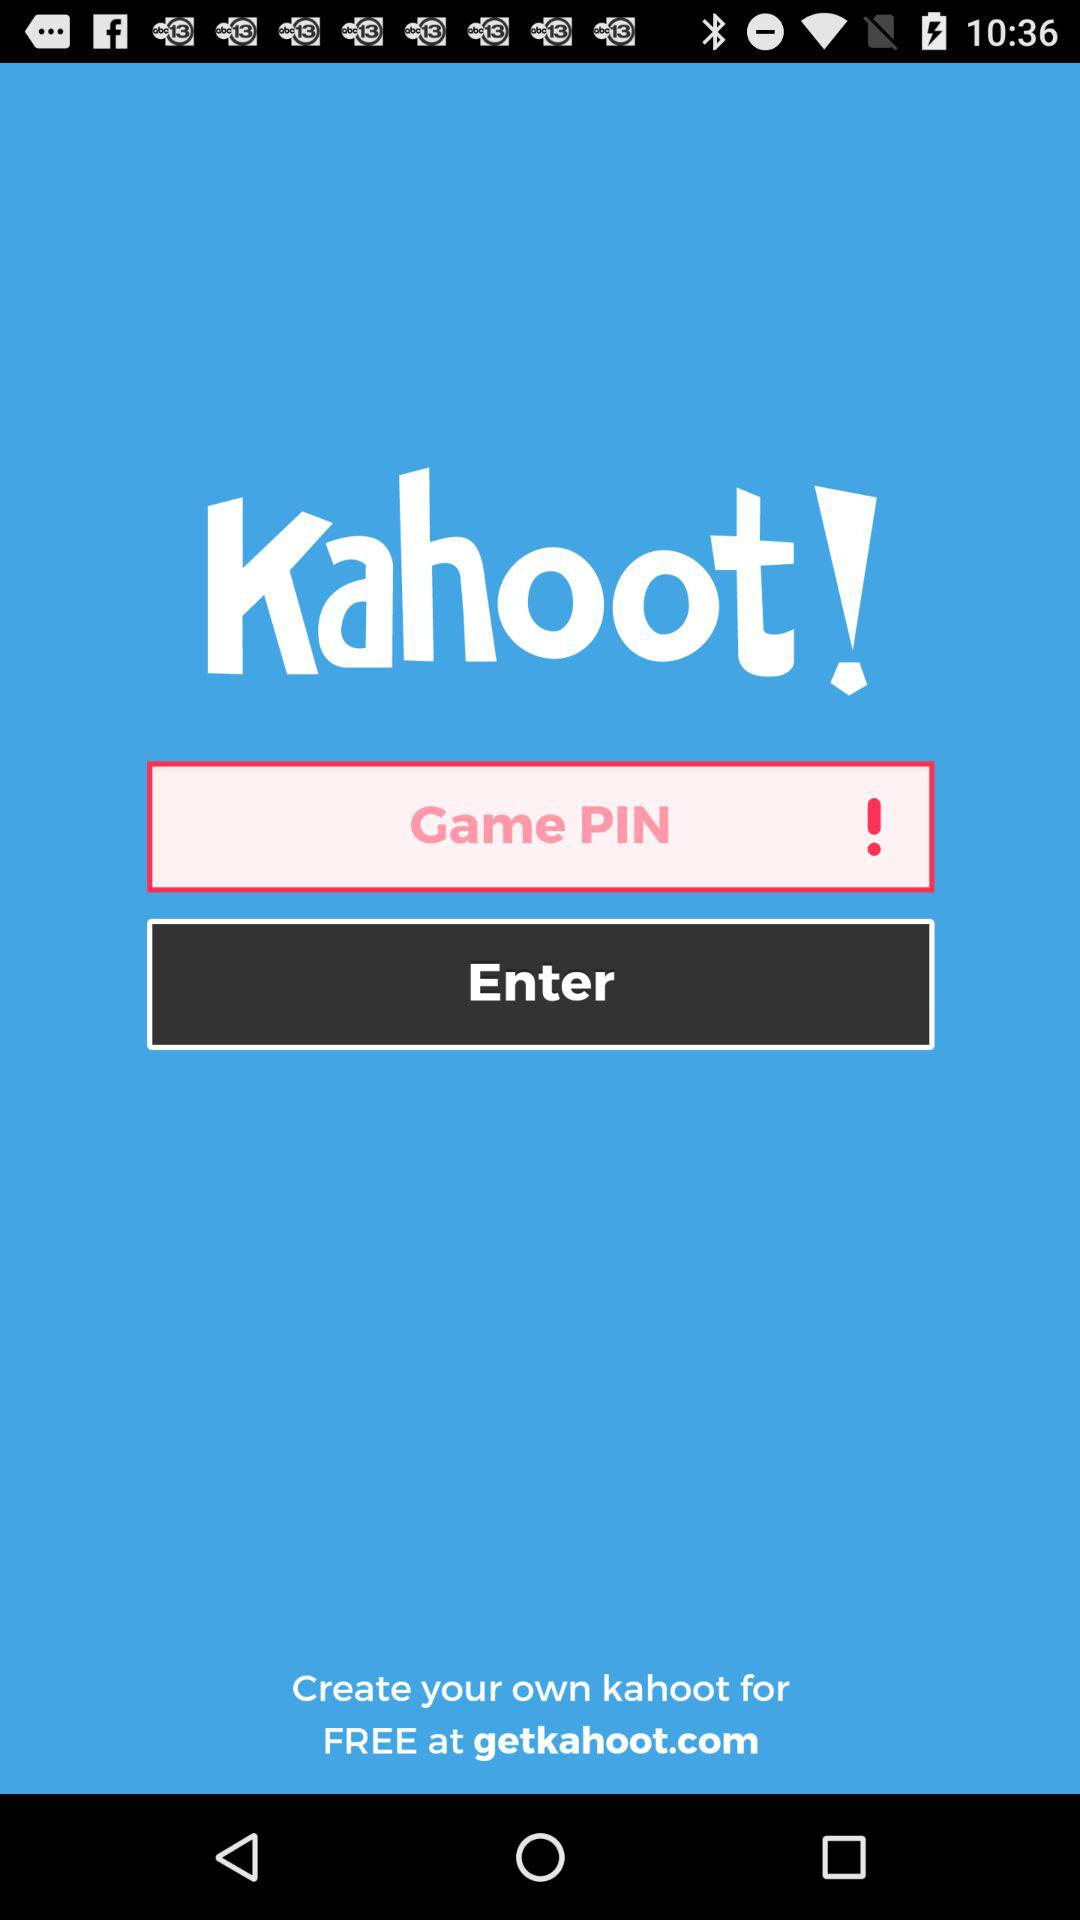What is the application name? The application name is "Kahoot!". 